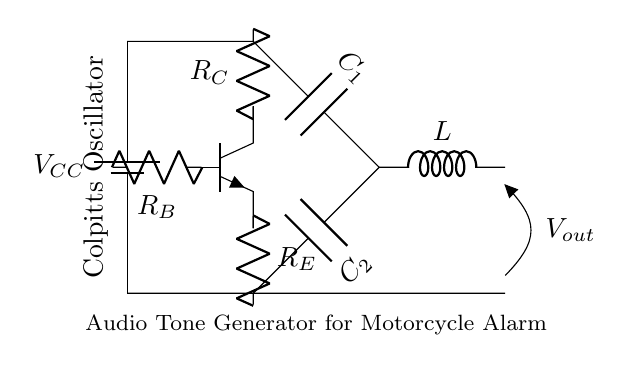What is the main function of this circuit? The main function of this circuit is to generate audio tones, specifically for use in motorcycle alarm systems. This is indicated by the labeling on the diagram that mentions its purpose directly.
Answer: Audio Tone Generator Which component provides frequency determination? The capacitors C1 and C2, along with the inductor L, form the resonant tank circuit that determines the frequency of the oscillation. The values of these components dictate the oscillation frequency.
Answer: Capacitors and Inductor How many resistors are there in this circuit? There are three resistors in the circuit, labeled as R_C, R_B, and R_E. They are connected respectively to the collector, base, and emitter of the transistor.
Answer: Three What is the purpose of the battery? The battery, labeled as V_CC, serves as the power supply for the entire circuit, providing the necessary voltage for the transistor to operate and for the oscillation to occur.
Answer: Power Supply What type of oscillator is this circuit? This circuit is a Colpitts oscillator, which is specifically characterized by its use of capacitors in series with the feedback components to create oscillation.
Answer: Colpitts oscillator Explain the significance of the inductor in this circuit. The inductor L plays a crucial role in forming the resonant circuit along with the capacitors, allowing for the combined reactive components to set the oscillation frequency. This inductive reactance complements the capacitive reactance to create oscillations.
Answer: Resonance 